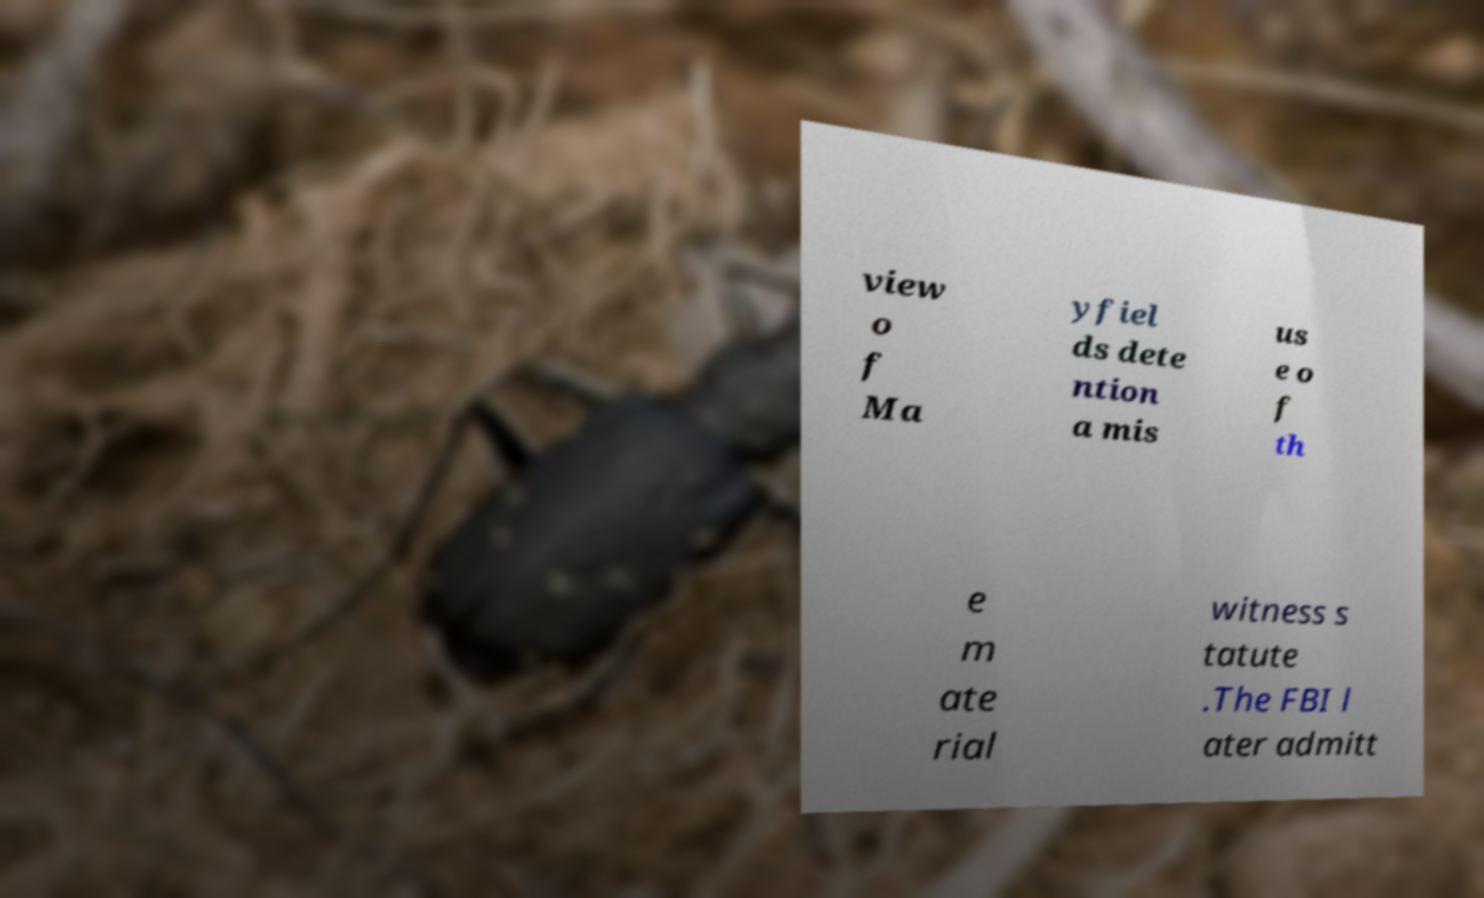For documentation purposes, I need the text within this image transcribed. Could you provide that? view o f Ma yfiel ds dete ntion a mis us e o f th e m ate rial witness s tatute .The FBI l ater admitt 